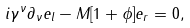Convert formula to latex. <formula><loc_0><loc_0><loc_500><loc_500>i \gamma ^ { \nu } \partial _ { \nu } e _ { l } - M [ 1 + \phi ] e _ { r } = 0 ,</formula> 